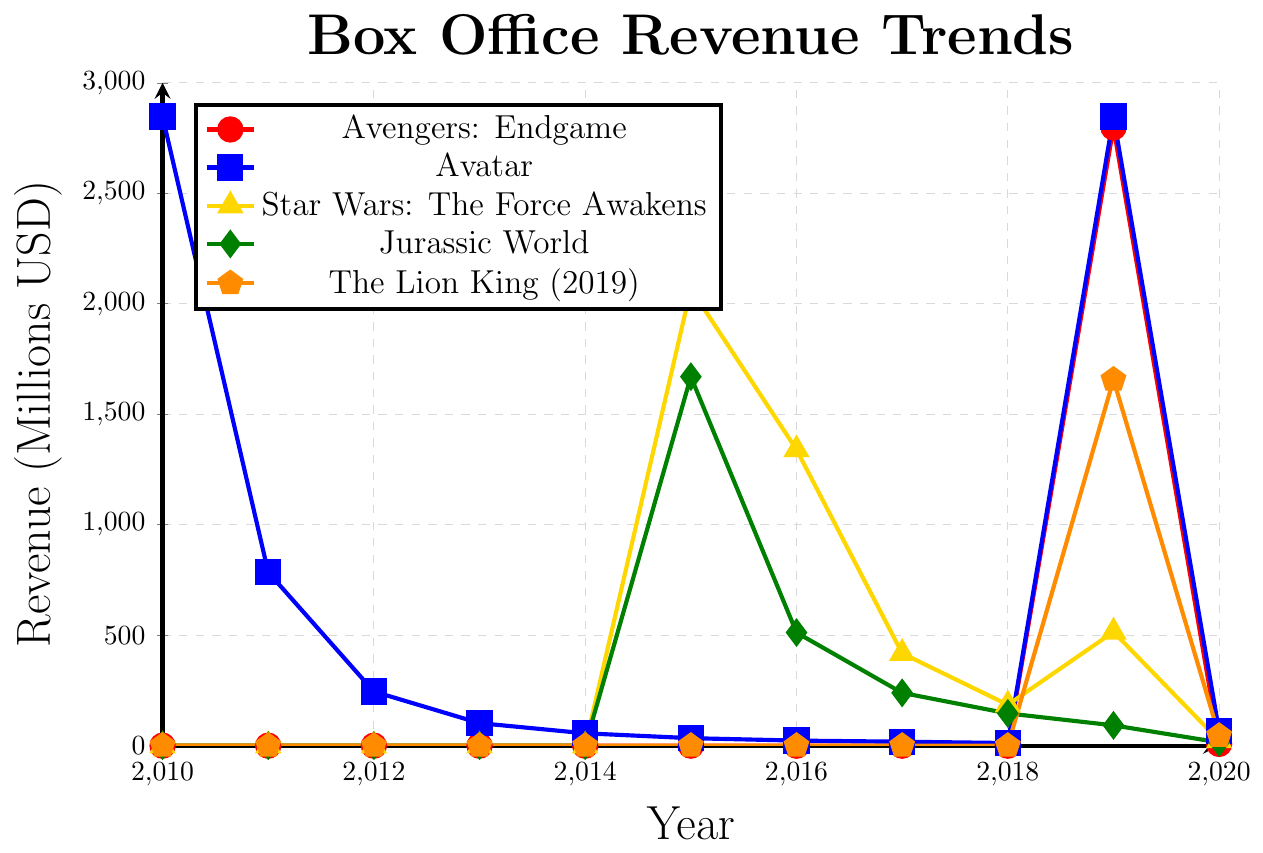Which film has the highest peak revenue and in which year? The highest peak revenue for the films in the chart is for "Avengers: Endgame" in 2019. This can be seen as the top-most point on the chart.
Answer: Avengers: Endgame in 2019 Which film had a revenue of 2847 million USD in two different years? Both in 2010 and 2019, "Avatar" had a revenue of 2847 million USD. This is seen as two distinct points on the chart with the same value for "Avatar."
Answer: Avatar How did the revenue for "Jurassic World" change from 2015 to 2020? In 2015, "Jurassic World" had a revenue of 1670 million USD, which decreased to 512 million USD in 2016, to 239 million USD in 2017, to 146 million USD in 2018, to 92 million USD in 2019, and finally to 15 million USD in 2020, showing a clear downward trend.
Answer: Decreased By how much did the revenue for "The Lion King (2019)" drop from 2019 to 2020? In 2019, the revenue for "The Lion King (2019)" was 1657 million USD, and in 2020, it was 45 million USD. The drop is 1657 - 45 = 1612 million USD.
Answer: 1612 million USD Which two films have similar revenue trends declining gradually every year except for peak values? "Avatar" and "Star Wars: The Force Awakens" show similar revenue trends where they had initial peak values followed by a gradual decline each year.
Answer: Avatar and Star Wars: The Force Awakens What is the combined revenue for "Avatar" and "Avengers: Endgame" in 2019? In 2019, "Avatar" had a revenue of 2847 million USD, and "Avengers: Endgame" had a revenue of 2798 million USD. The combined revenue is 2847 + 2798 = 5645 million USD.
Answer: 5645 million USD Which film's revenue remains constant in specific years? "Avatar" has the same revenue of 2847 million USD in both 2010 and 2019, showing a constant revenue for those specific years.
Answer: Avatar Which film is represented by the green-colored line in the chart? The green-colored line represents "Jurassic World" in the chart. This is evident by the color distinction used in the legend.
Answer: Jurassic World In which year did "Star Wars: The Force Awakens" have its maximum revenue, and what was the revenue? "Star Wars: The Force Awakens" had its maximum revenue in 2015, which was 2068 million USD. This can be observed from the peak point of its line on the chart.
Answer: 2015, 2068 million USD Compare the revenue in 2020 for "Avatar" and "The Lion King (2019)." Which one was higher and by how much? In 2020, "Avatar" had a revenue of 65 million USD and "The Lion King (2019)" had a revenue of 45 million USD. "Avatar" had a higher revenue by 65 - 45 = 20 million USD.
Answer: Avatar by 20 million USD 